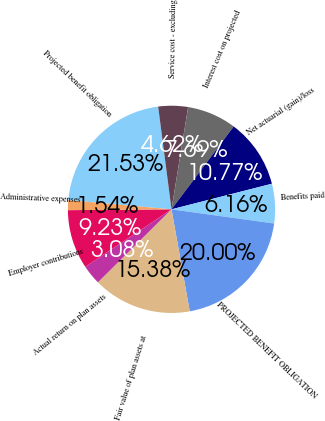Convert chart. <chart><loc_0><loc_0><loc_500><loc_500><pie_chart><fcel>Projected benefit obligation<fcel>Service cost - excluding<fcel>Interest cost on projected<fcel>Net actuarial (gain)/loss<fcel>Benefits paid<fcel>PROJECTED BENEFIT OBLIGATION<fcel>Fair value of plan assets at<fcel>Actual return on plan assets<fcel>Employer contributions<fcel>Administrative expenses<nl><fcel>21.53%<fcel>4.62%<fcel>7.69%<fcel>10.77%<fcel>6.16%<fcel>20.0%<fcel>15.38%<fcel>3.08%<fcel>9.23%<fcel>1.54%<nl></chart> 